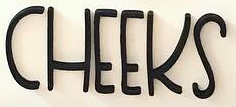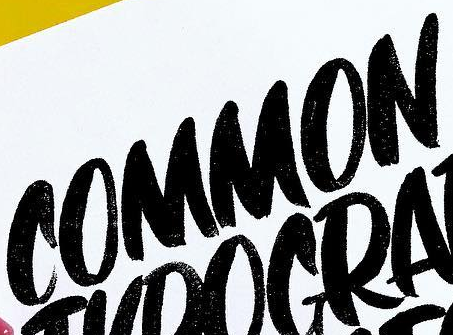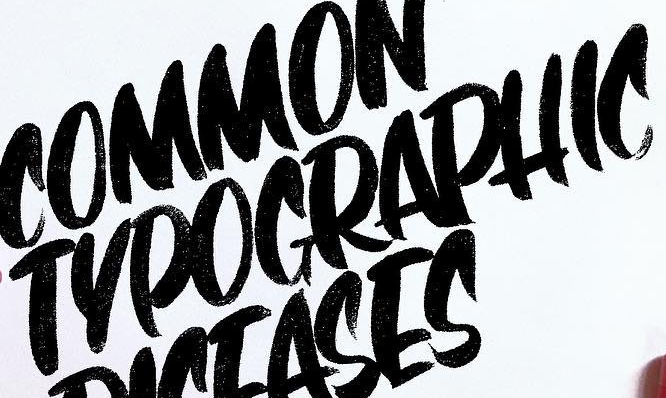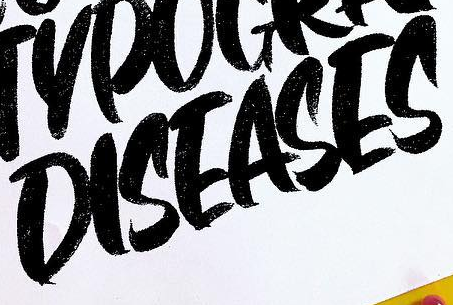What words can you see in these images in sequence, separated by a semicolon? CHEEKS; COMMON; TYPOGRAPHIC; DISEASES 